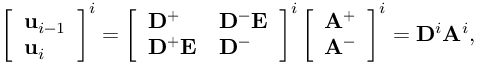Convert formula to latex. <formula><loc_0><loc_0><loc_500><loc_500>\left [ \begin{array} { l } { u _ { i - 1 } } \\ { u _ { i } } \end{array} \right ] ^ { i } = \left [ \begin{array} { l l } { D ^ { + } } & { D ^ { - } E } \\ { D ^ { + } E } & { D ^ { - } } \end{array} \right ] ^ { i } \left [ \begin{array} { l } { A ^ { + } } \\ { A ^ { - } } \end{array} \right ] ^ { i } = D ^ { i } A ^ { i } ,</formula> 